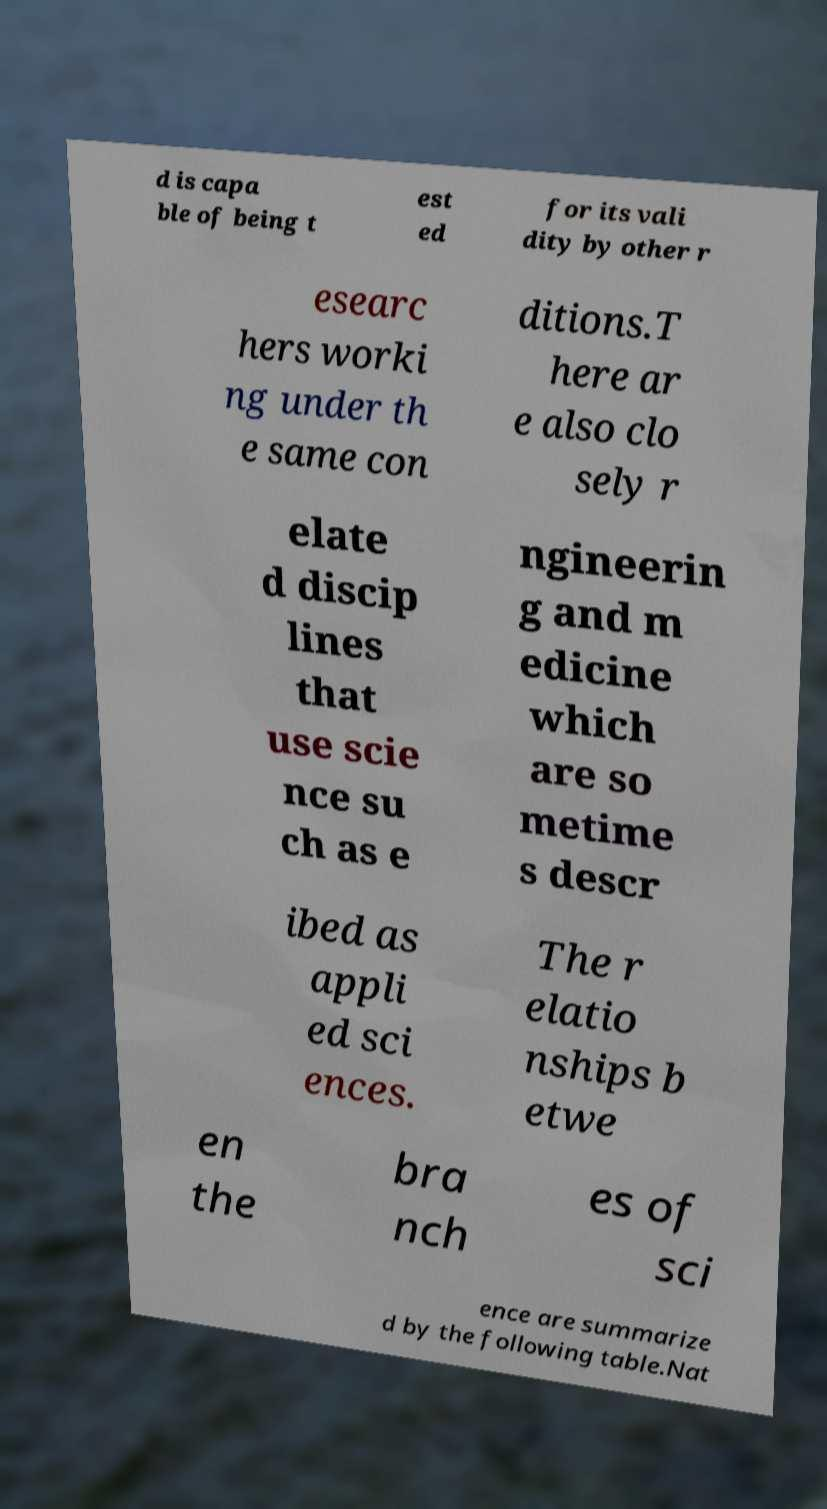I need the written content from this picture converted into text. Can you do that? d is capa ble of being t est ed for its vali dity by other r esearc hers worki ng under th e same con ditions.T here ar e also clo sely r elate d discip lines that use scie nce su ch as e ngineerin g and m edicine which are so metime s descr ibed as appli ed sci ences. The r elatio nships b etwe en the bra nch es of sci ence are summarize d by the following table.Nat 